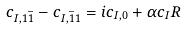Convert formula to latex. <formula><loc_0><loc_0><loc_500><loc_500>c _ { I , 1 { \bar { 1 } } } - c _ { I , { \bar { 1 } } 1 } = i c _ { I , 0 } + { \alpha } c _ { I } R</formula> 